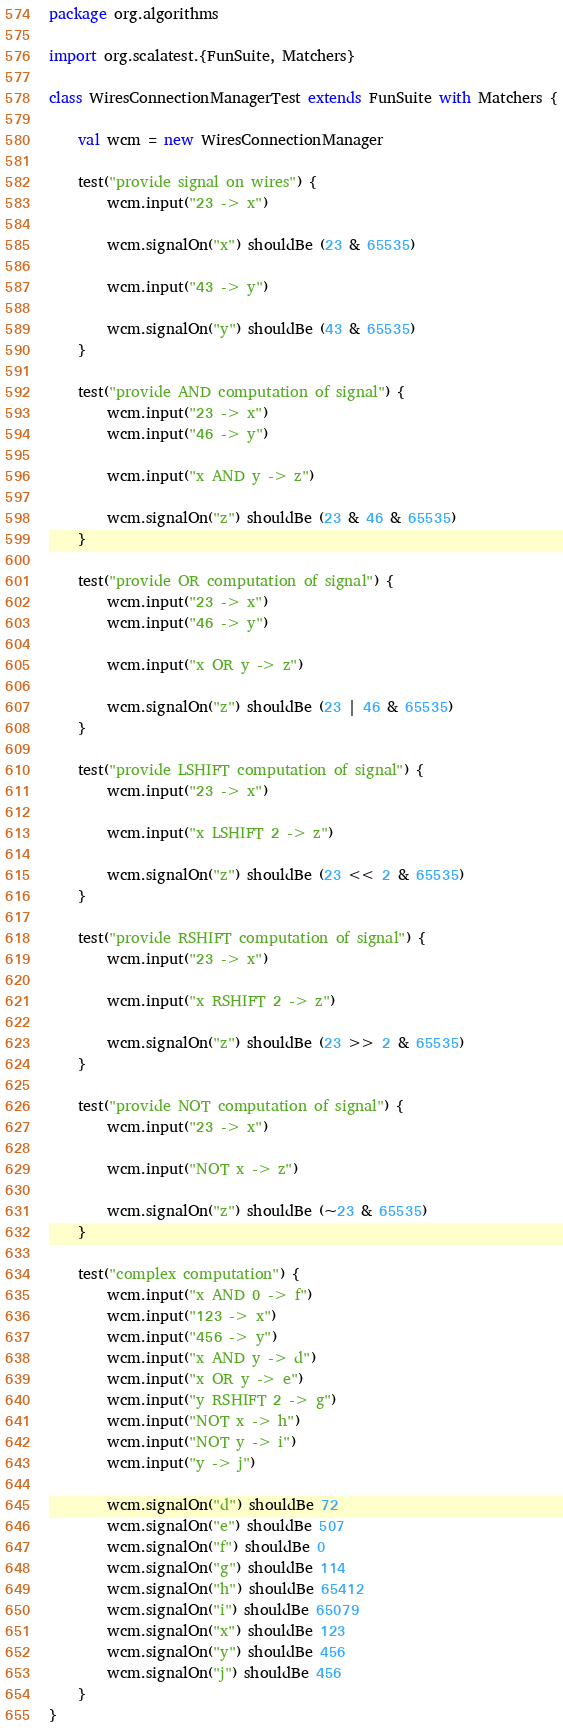Convert code to text. <code><loc_0><loc_0><loc_500><loc_500><_Scala_>package org.algorithms

import org.scalatest.{FunSuite, Matchers}

class WiresConnectionManagerTest extends FunSuite with Matchers {

    val wcm = new WiresConnectionManager

    test("provide signal on wires") {
        wcm.input("23 -> x")

        wcm.signalOn("x") shouldBe (23 & 65535)

        wcm.input("43 -> y")

        wcm.signalOn("y") shouldBe (43 & 65535)
    }

    test("provide AND computation of signal") {
        wcm.input("23 -> x")
        wcm.input("46 -> y")

        wcm.input("x AND y -> z")

        wcm.signalOn("z") shouldBe (23 & 46 & 65535)
    }

    test("provide OR computation of signal") {
        wcm.input("23 -> x")
        wcm.input("46 -> y")

        wcm.input("x OR y -> z")

        wcm.signalOn("z") shouldBe (23 | 46 & 65535)
    }

    test("provide LSHIFT computation of signal") {
        wcm.input("23 -> x")

        wcm.input("x LSHIFT 2 -> z")

        wcm.signalOn("z") shouldBe (23 << 2 & 65535)
    }

    test("provide RSHIFT computation of signal") {
        wcm.input("23 -> x")

        wcm.input("x RSHIFT 2 -> z")

        wcm.signalOn("z") shouldBe (23 >> 2 & 65535)
    }

    test("provide NOT computation of signal") {
        wcm.input("23 -> x")

        wcm.input("NOT x -> z")

        wcm.signalOn("z") shouldBe (~23 & 65535)
    }

    test("complex computation") {
        wcm.input("x AND 0 -> f")
        wcm.input("123 -> x")
        wcm.input("456 -> y")
        wcm.input("x AND y -> d")
        wcm.input("x OR y -> e")
        wcm.input("y RSHIFT 2 -> g")
        wcm.input("NOT x -> h")
        wcm.input("NOT y -> i")
        wcm.input("y -> j")

        wcm.signalOn("d") shouldBe 72
        wcm.signalOn("e") shouldBe 507
        wcm.signalOn("f") shouldBe 0
        wcm.signalOn("g") shouldBe 114
        wcm.signalOn("h") shouldBe 65412
        wcm.signalOn("i") shouldBe 65079
        wcm.signalOn("x") shouldBe 123
        wcm.signalOn("y") shouldBe 456
        wcm.signalOn("j") shouldBe 456
    }
}
</code> 